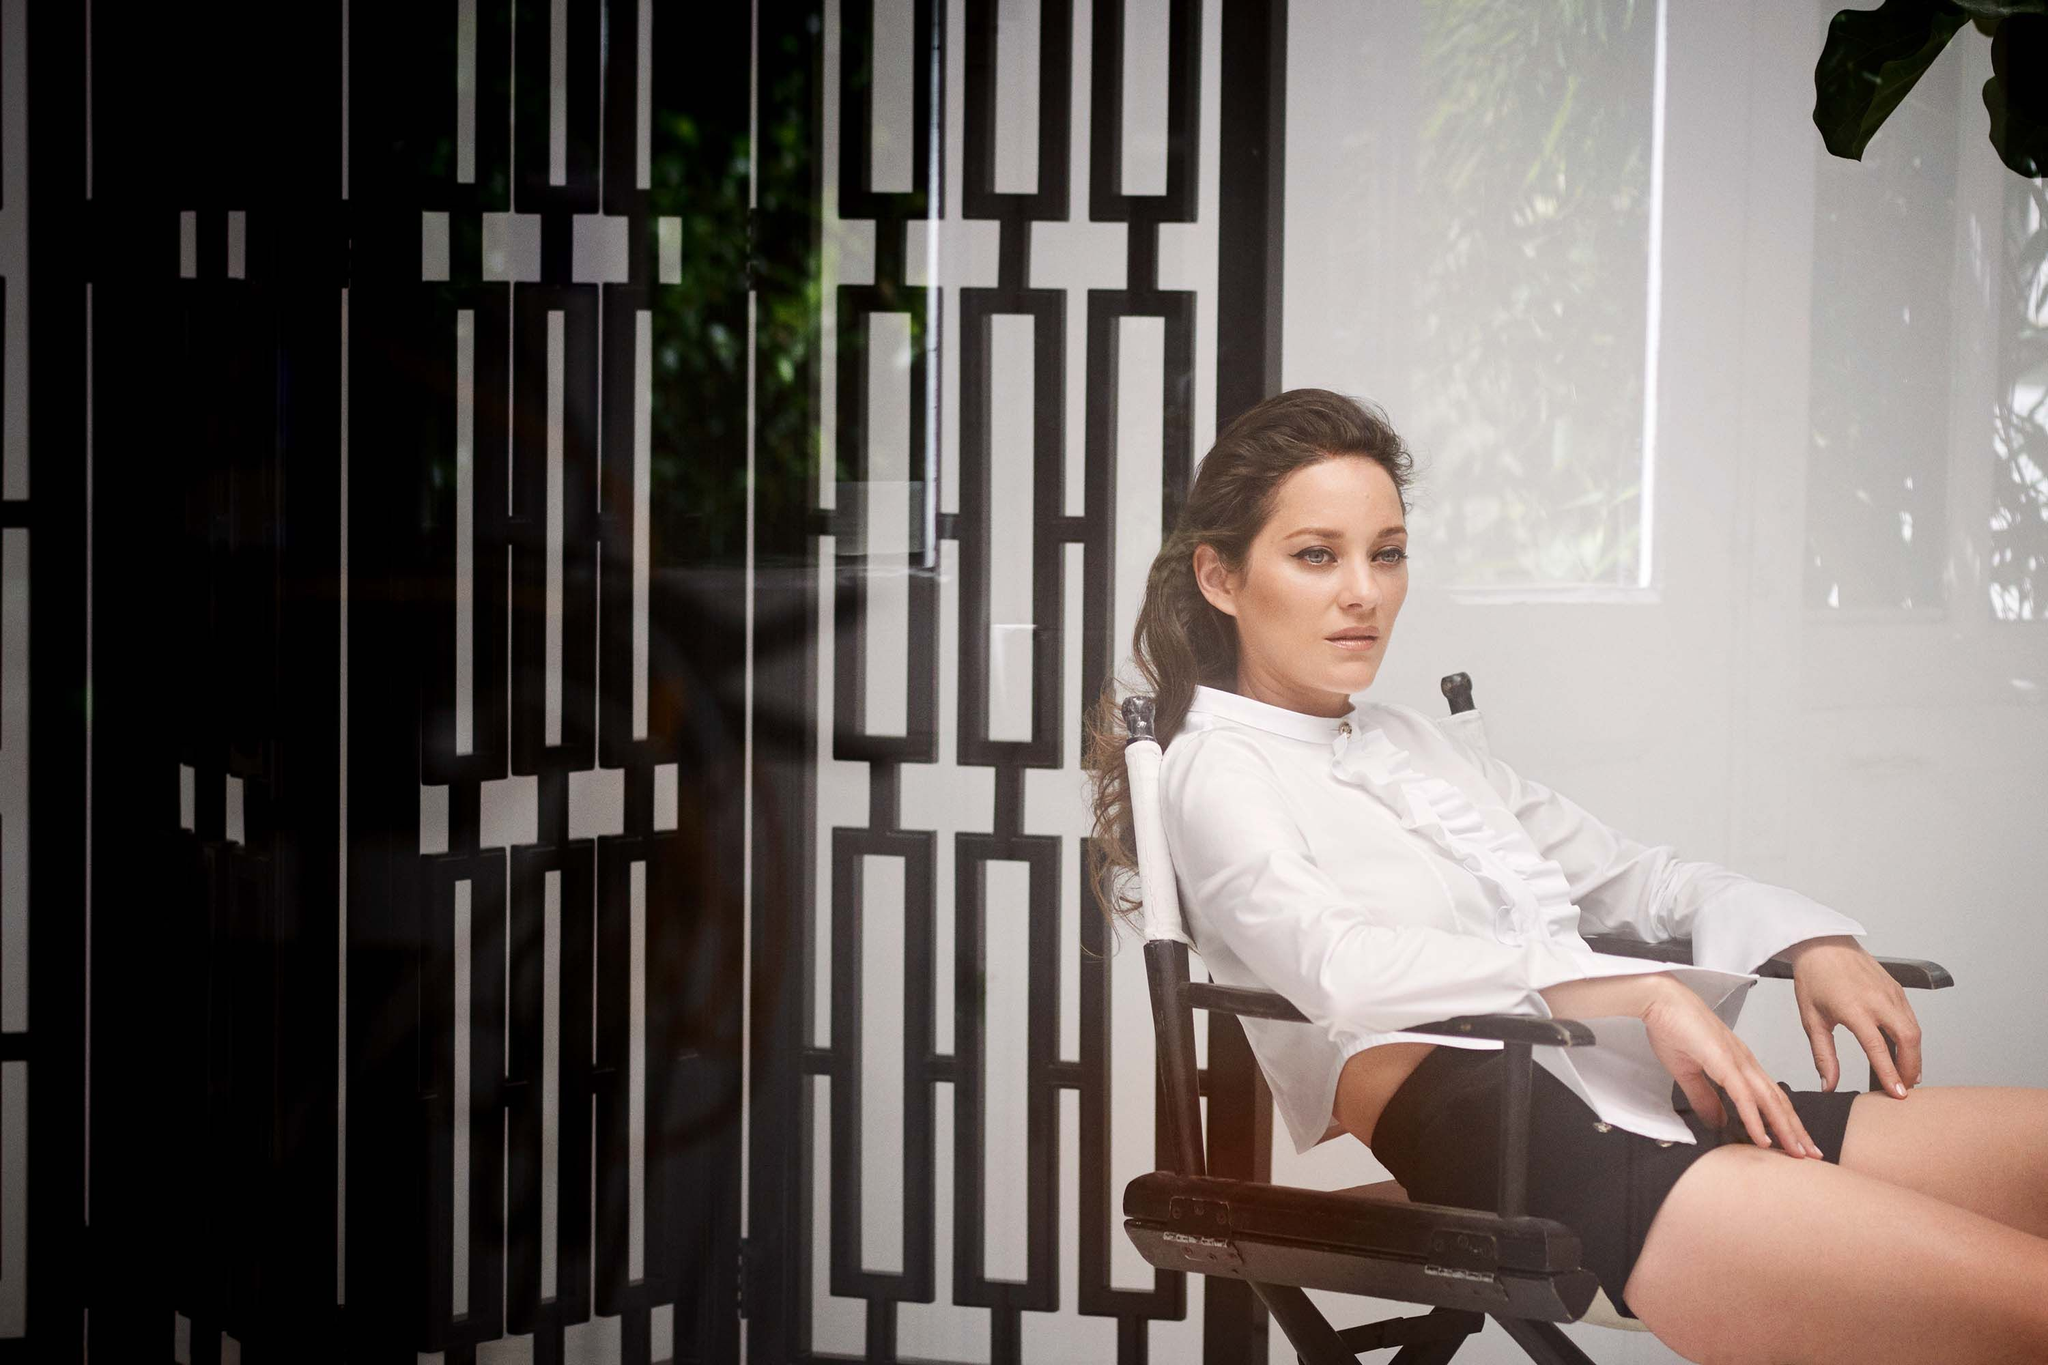How does the attire of the woman contribute to the overall theme of the photograph? Her attire, consisting of a crisp white blouse and black shorts, contributes significantly to the overall monochromatic theme of the photograph. This simplistic but elegant choice of clothing exudes sophistication and understated style. Additionally, the white blouse might symbolize purity or clarity, while the black shorts could offer a contrasting groundedness, mirroring the duality of thoughtfulness and the stark geometric patterns in the background. Imagine the conversation she might be having in her mind. What might it be? In her mind, she might be reflecting on the scenes she has performed, mentally preparing for the next segment of filming. Thoughts might weave through her past experiences, her current emotions, and the depth of the character she portrays. She could be evaluating her performance, pondering the nuances of her role, and considering how she can bring more authenticity and depth to her next scene. This reflective moment encapsulates the dedication and passion she holds for her craft. Create a very creative question about this image. If this directing chair had the ability to gather and project the thoughts of every person who ever sat on it, what kind of stories and emotions do you think it would convey, and how would those moments intertwine with the geometric patterns on the wall? 